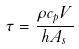Convert formula to latex. <formula><loc_0><loc_0><loc_500><loc_500>\tau = \frac { \rho c _ { p } V } { h A _ { s } }</formula> 